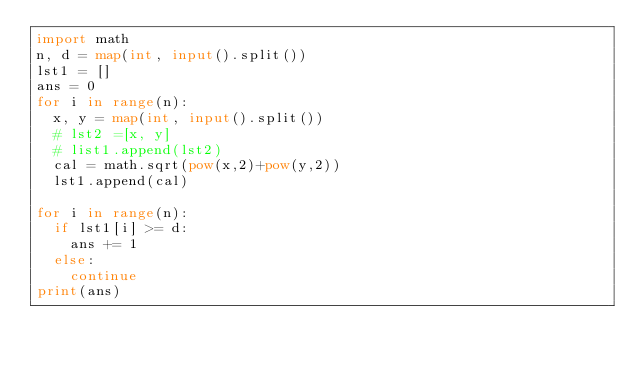<code> <loc_0><loc_0><loc_500><loc_500><_Python_>import math
n, d = map(int, input().split())
lst1 = []
ans = 0
for i in range(n):
  x, y = map(int, input().split())
  # lst2 =[x, y]
  # list1.append(lst2)
  cal = math.sqrt(pow(x,2)+pow(y,2))
  lst1.append(cal)
  
for i in range(n):
  if lst1[i] >= d:
    ans += 1
  else:
    continue
print(ans)
</code> 